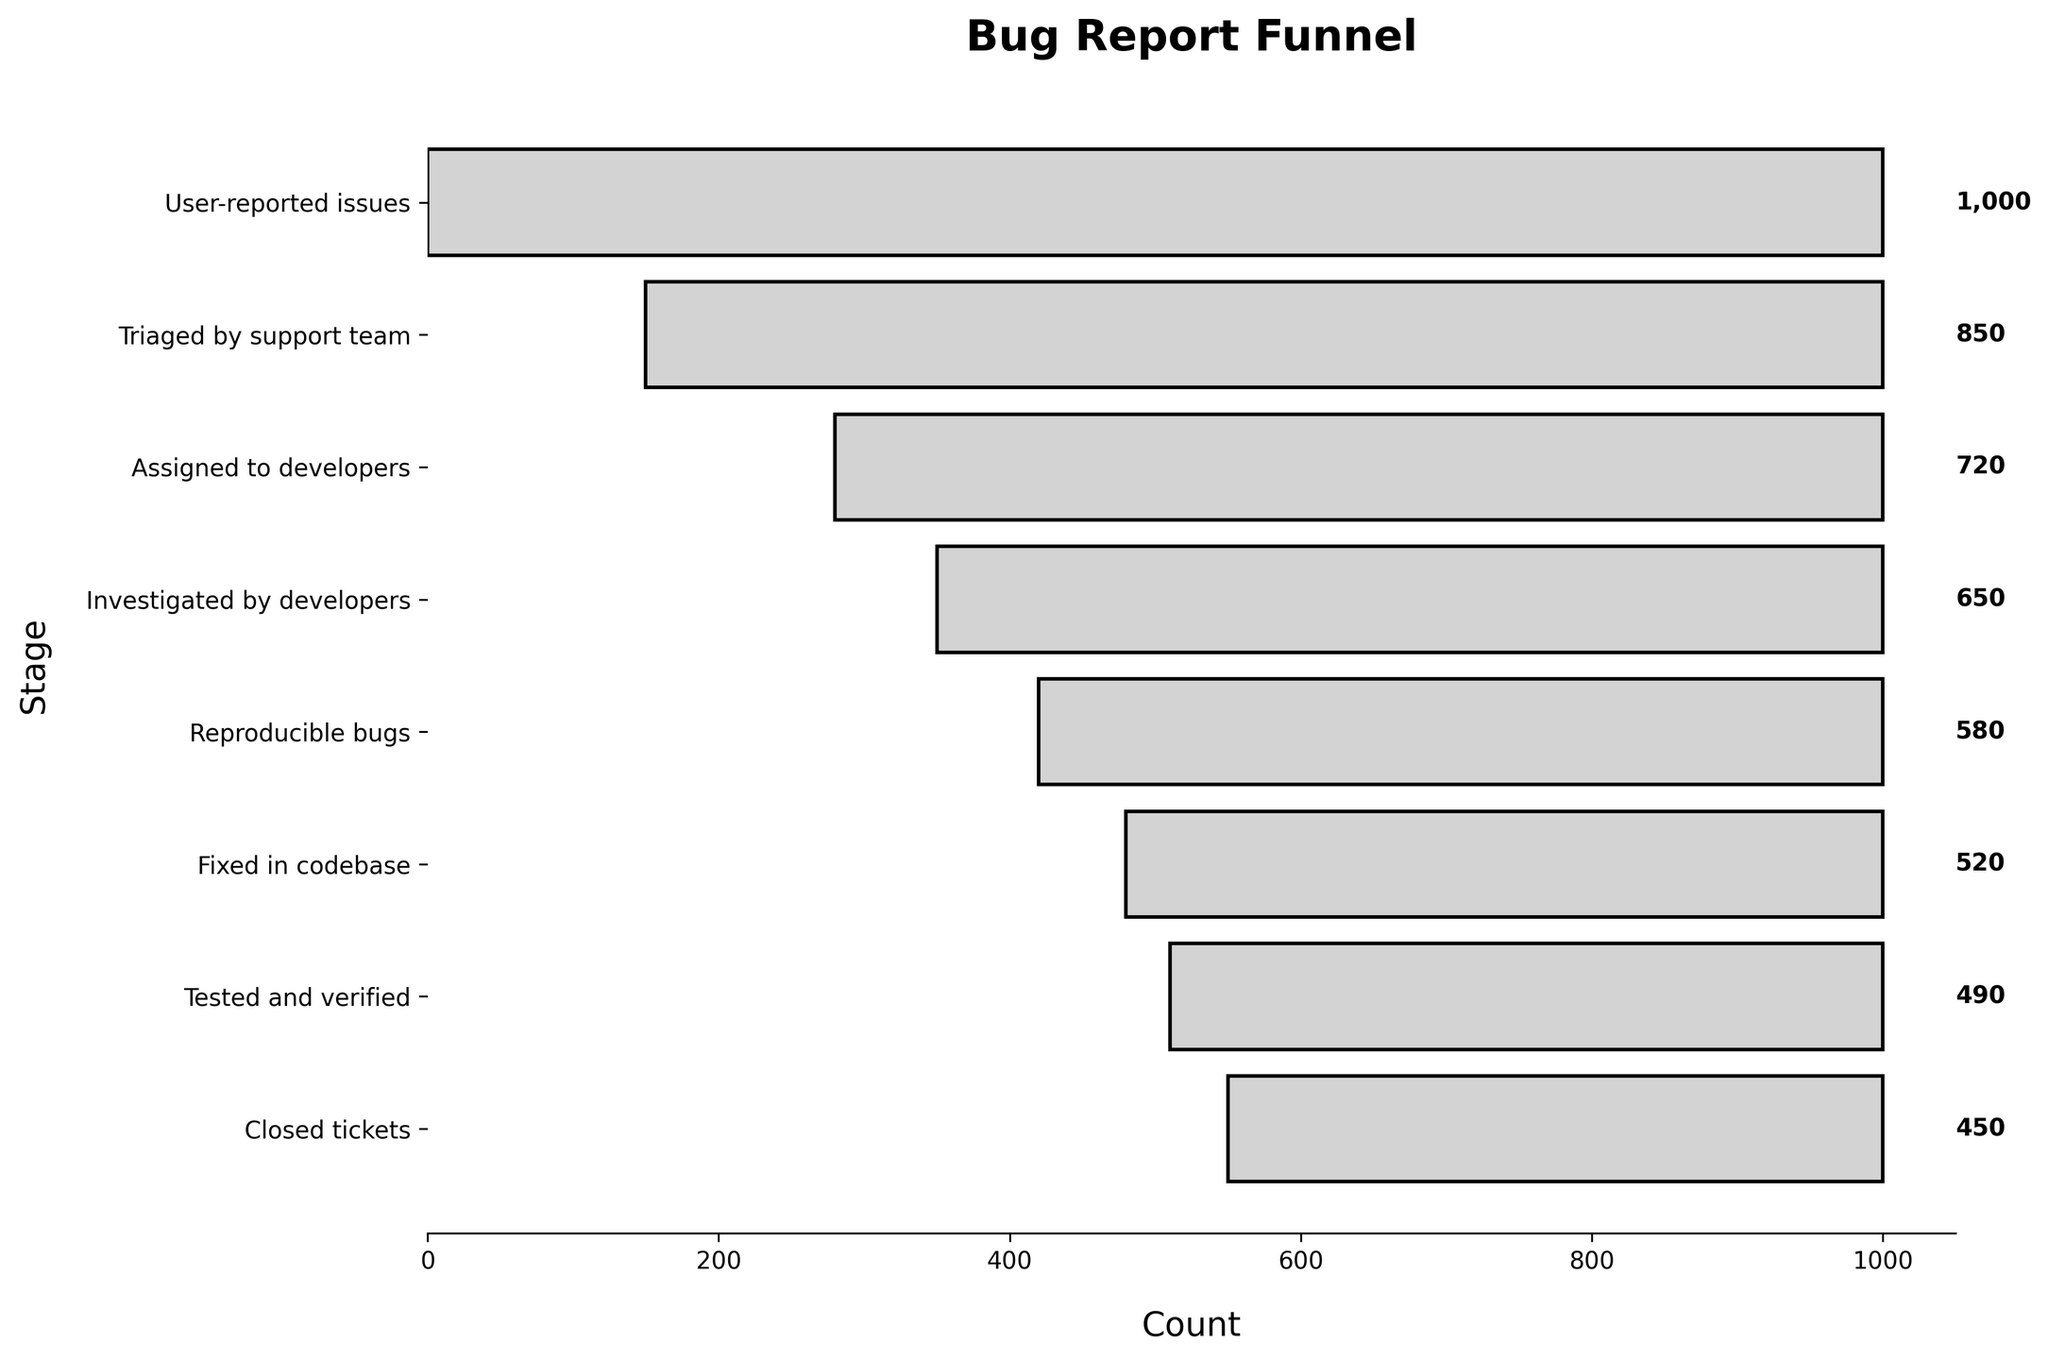What is the title of the chart? The title of the chart is located at the top of the chart, displayed prominently in a larger and bold font.
Answer: Bug Report Funnel How many stages are there in the bug report funnel? You can count the number of unique stages listed on the vertical axis (y-axis) of the funnel chart.
Answer: 8 What is the count of 'Fixed in codebase'? To find the count for 'Fixed in codebase', locate the corresponding stage on the y-axis and read the associated value on the bar.
Answer: 520 How many more issues are 'Triaged by the support team' compared to 'Assigned to developers'? Subtract the count of issues 'Assigned to developers' from the count of issues 'Triaged by the support team'. According to the funnel data, 850 (Triaged by support team) - 720 (Assigned to developers) = 130.
Answer: 130 What is the average count of issues in the stages from 'Triaged by support team' to 'Closed tickets'? First, sum the counts from the stages 'Triaged by support team' to 'Closed tickets', then divide by the number of stages. (850 + 720 + 650 + 580 + 520 + 490 + 450) / 7 = 4,260 / 7 = 608.57 (rounded to two decimal places).
Answer: 608.57 Which stage has the highest count of issues? To determine the stage with the highest count, compare the counts of each stage listed in the funnel chart. The stage with the highest count is 'User-reported issues'.
Answer: User-reported issues What percentage of 'User-reported issues' were eventually 'Closed tickets'? Calculate the percentage by dividing the number of 'Closed tickets' by 'User-reported issues' and then multiply by 100. \( \left( \frac{450}{1000} \right) * 100 = 45\% \)
Answer: 45% Which two stages have the closest number of issues? Look at the counts for each stage and identify the pair with the smallest difference. The closest counts are between 'Tested and verified' (490) and 'Closed tickets' (450). The difference is 490 - 450 = 40.
Answer: Tested and verified and Closed tickets If 10% of 'Triaged by support team' are false reports, how many valid triages were there? Calculate 10% of 'Triaged by support team' and subtract from the original count. \( 850 \times 0.1 = 85 \) \( 850 - 85 = 765 \)
Answer: 765 